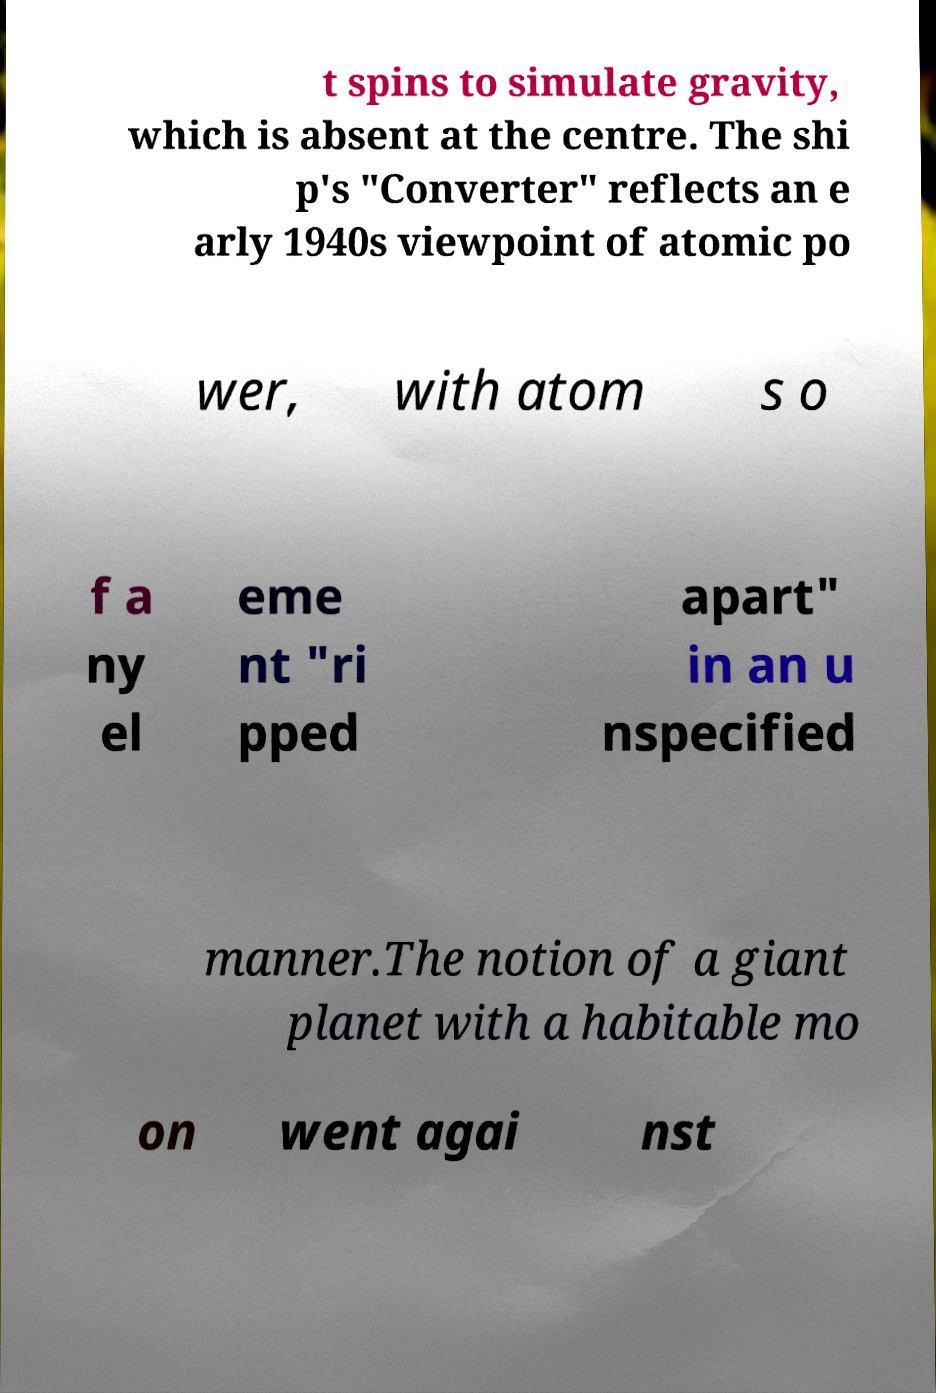For documentation purposes, I need the text within this image transcribed. Could you provide that? t spins to simulate gravity, which is absent at the centre. The shi p's "Converter" reflects an e arly 1940s viewpoint of atomic po wer, with atom s o f a ny el eme nt "ri pped apart" in an u nspecified manner.The notion of a giant planet with a habitable mo on went agai nst 